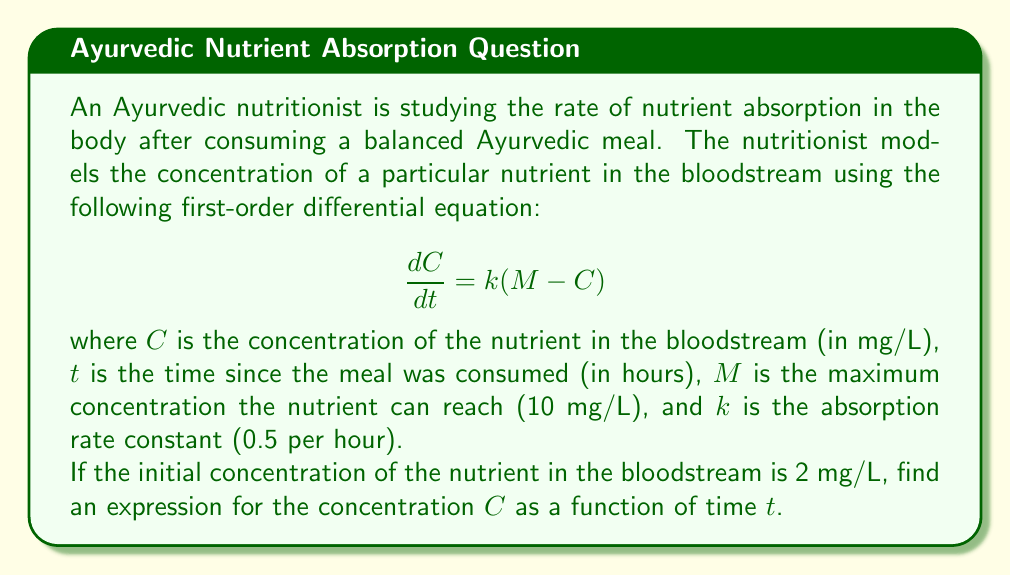Help me with this question. To solve this first-order differential equation, we'll follow these steps:

1) First, we recognize this as a linear first-order differential equation in the form:

   $$\frac{dC}{dt} + kC = kM$$

2) The integrating factor for this equation is $e^{\int k dt} = e^{kt}$.

3) Multiplying both sides of the equation by the integrating factor:

   $$e^{kt}\frac{dC}{dt} + ke^{kt}C = kMe^{kt}$$

4) The left side is now the derivative of $e^{kt}C$:

   $$\frac{d}{dt}(e^{kt}C) = kMe^{kt}$$

5) Integrating both sides:

   $$e^{kt}C = M + Ae^{kt}$$

   where $A$ is a constant of integration.

6) Solving for $C$:

   $$C = M + Ae^{-kt}$$

7) To find $A$, we use the initial condition. At $t=0$, $C=2$:

   $$2 = M + A$$
   $$A = 2 - M = 2 - 10 = -8$$

8) Substituting this back into our solution:

   $$C = M - 8e^{-kt}$$

9) Finally, substituting the given values for $M$ and $k$:

   $$C = 10 - 8e^{-0.5t}$$

This is the expression for the concentration $C$ as a function of time $t$.
Answer: $C = 10 - 8e^{-0.5t}$, where $C$ is in mg/L and $t$ is in hours. 